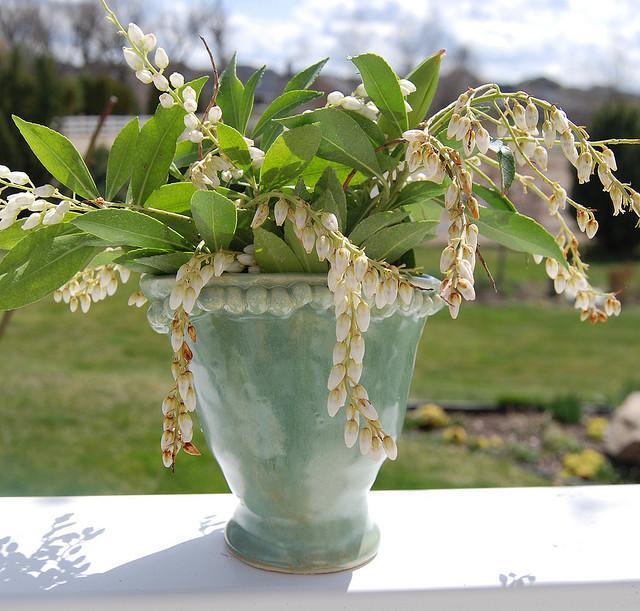How many people are wearing a hat?
Give a very brief answer. 0. 